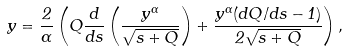<formula> <loc_0><loc_0><loc_500><loc_500>y = \frac { 2 } { \alpha } \left ( Q \frac { d } { d s } \left ( \frac { y ^ { \alpha } } { \sqrt { s + Q } } \right ) + \frac { y ^ { \alpha } ( d Q / d s - 1 ) } { 2 \sqrt { s + Q } } \right ) ,</formula> 